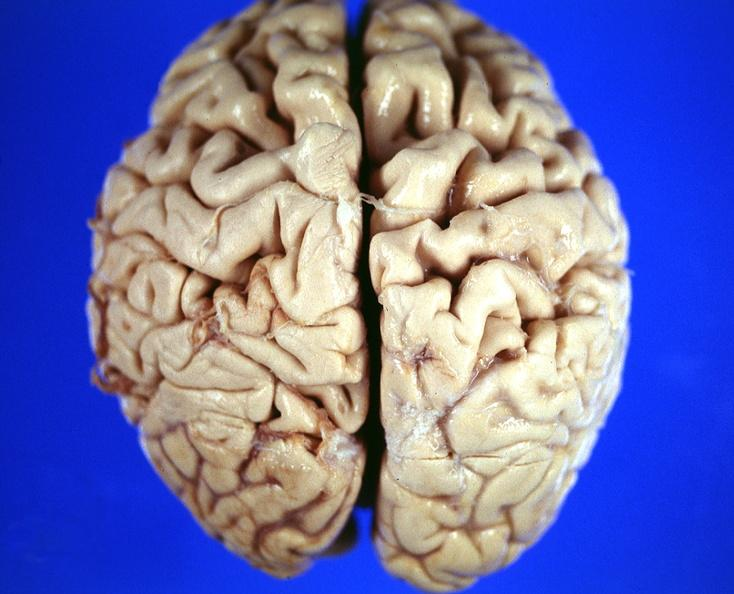does excellent close-up view show brain, frontal lobe atrophy, pick 's disease?
Answer the question using a single word or phrase. No 